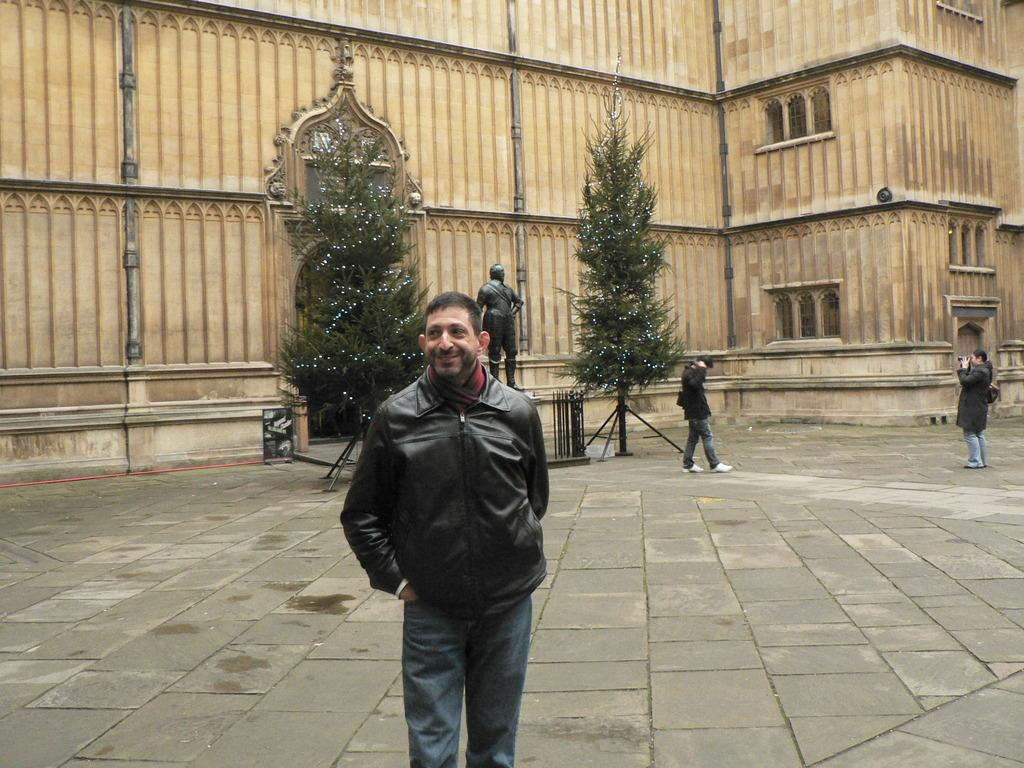How many people are present in the image? There are three people in the image. What are two of the people doing in the image? Two of the people are holding objects. What type of structure can be seen in the image? There is a building in the image. What artistic feature is present in the image? There is a sculpture in the image. What type of vegetation is visible in the image? There are trees in the image. What architectural elements can be seen in the building? There are windows in the image. What type of cooking equipment is present in the image? There are grills in the image. What type of glass is being used by the people in the image? There is no glass present in the image. 